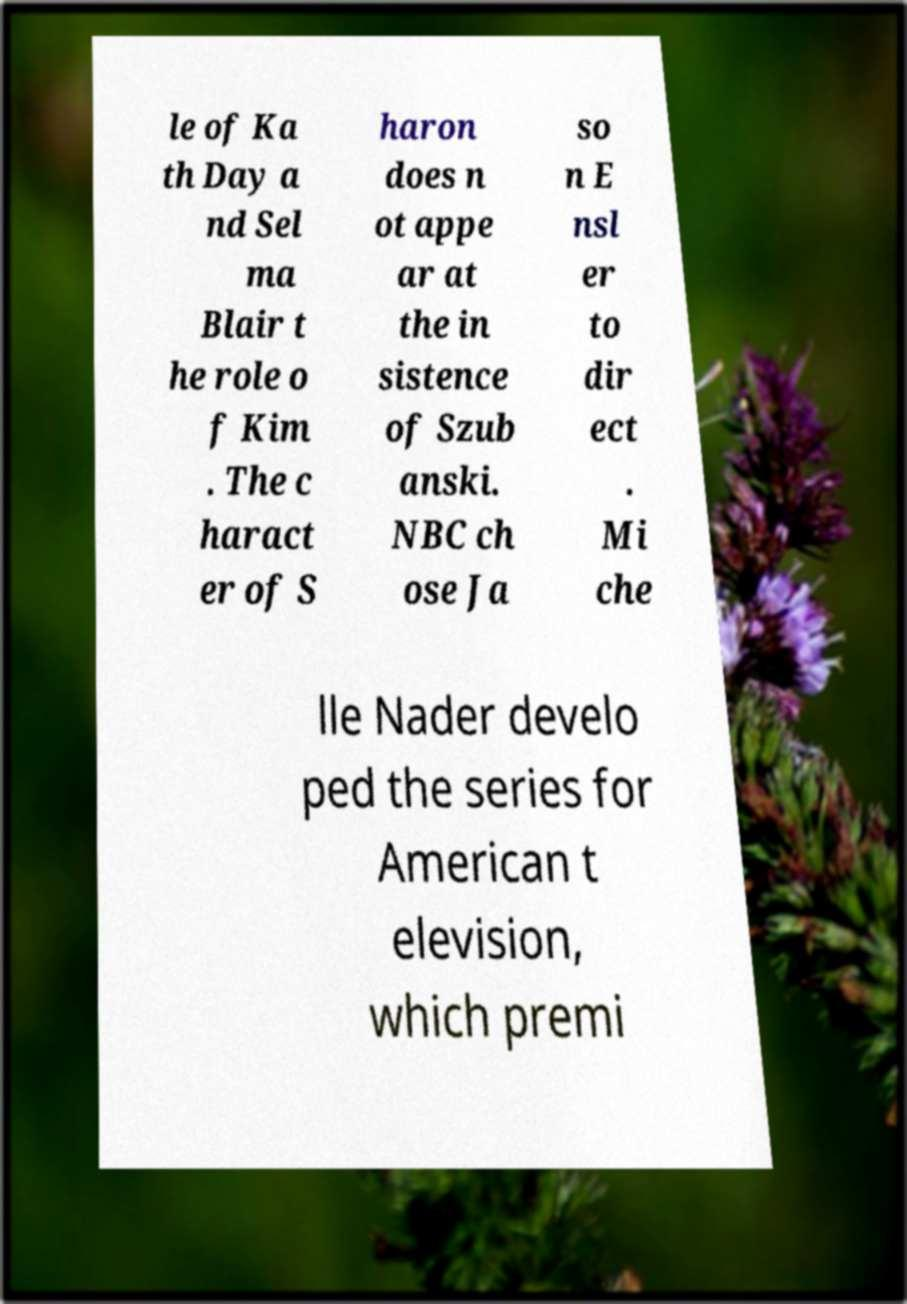There's text embedded in this image that I need extracted. Can you transcribe it verbatim? le of Ka th Day a nd Sel ma Blair t he role o f Kim . The c haract er of S haron does n ot appe ar at the in sistence of Szub anski. NBC ch ose Ja so n E nsl er to dir ect . Mi che lle Nader develo ped the series for American t elevision, which premi 